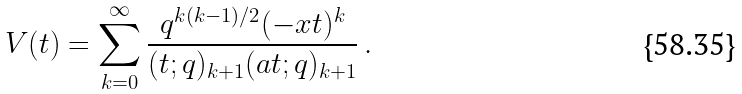<formula> <loc_0><loc_0><loc_500><loc_500>V ( t ) = \sum _ { k = 0 } ^ { \infty } \frac { q ^ { k ( k - 1 ) / 2 } ( - x t ) ^ { k } } { ( t ; q ) _ { k + 1 } ( a t ; q ) _ { k + 1 } } \, .</formula> 